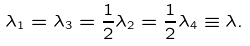<formula> <loc_0><loc_0><loc_500><loc_500>\lambda _ { 1 } = \lambda _ { 3 } = \frac { 1 } { 2 } \lambda _ { 2 } = \frac { 1 } { 2 } \lambda _ { 4 } \equiv \lambda .</formula> 